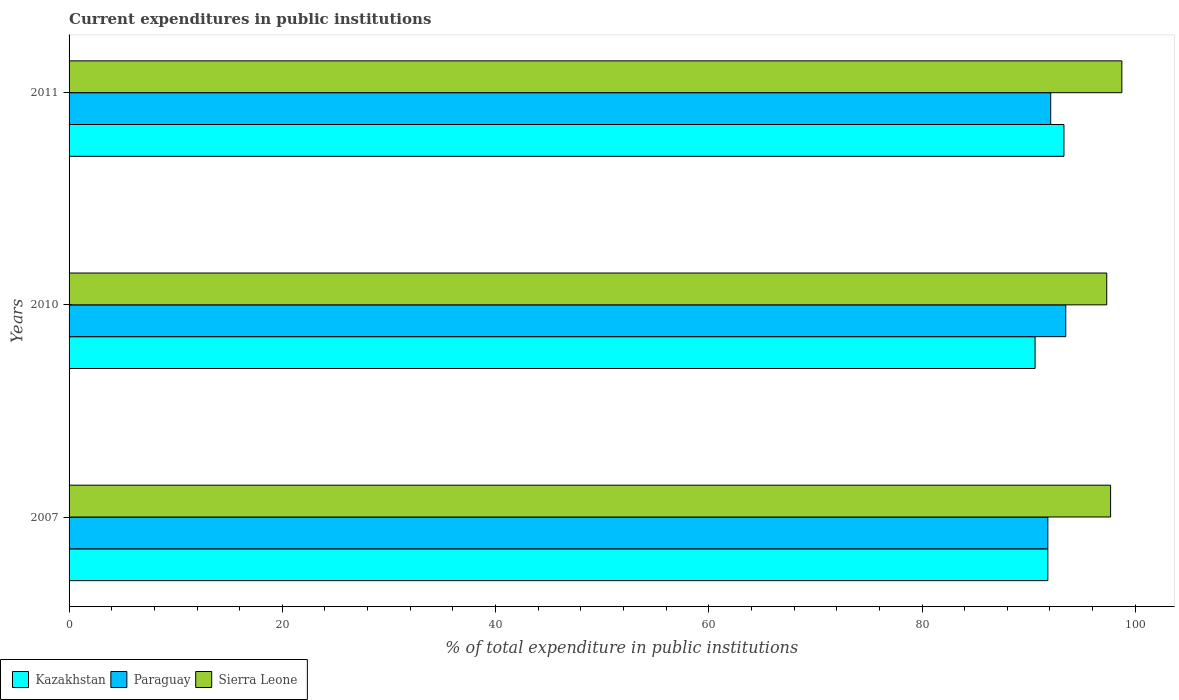How many different coloured bars are there?
Give a very brief answer. 3. Are the number of bars per tick equal to the number of legend labels?
Give a very brief answer. Yes. What is the current expenditures in public institutions in Sierra Leone in 2007?
Offer a terse response. 97.69. Across all years, what is the maximum current expenditures in public institutions in Kazakhstan?
Provide a succinct answer. 93.31. Across all years, what is the minimum current expenditures in public institutions in Sierra Leone?
Provide a short and direct response. 97.33. What is the total current expenditures in public institutions in Paraguay in the graph?
Give a very brief answer. 277.35. What is the difference between the current expenditures in public institutions in Sierra Leone in 2010 and that in 2011?
Give a very brief answer. -1.42. What is the difference between the current expenditures in public institutions in Kazakhstan in 2010 and the current expenditures in public institutions in Sierra Leone in 2011?
Make the answer very short. -8.14. What is the average current expenditures in public institutions in Kazakhstan per year?
Make the answer very short. 91.91. In the year 2007, what is the difference between the current expenditures in public institutions in Paraguay and current expenditures in public institutions in Sierra Leone?
Keep it short and to the point. -5.89. In how many years, is the current expenditures in public institutions in Sierra Leone greater than 4 %?
Ensure brevity in your answer.  3. What is the ratio of the current expenditures in public institutions in Kazakhstan in 2007 to that in 2010?
Your answer should be very brief. 1.01. Is the current expenditures in public institutions in Paraguay in 2010 less than that in 2011?
Keep it short and to the point. No. Is the difference between the current expenditures in public institutions in Paraguay in 2007 and 2011 greater than the difference between the current expenditures in public institutions in Sierra Leone in 2007 and 2011?
Keep it short and to the point. Yes. What is the difference between the highest and the second highest current expenditures in public institutions in Sierra Leone?
Ensure brevity in your answer.  1.06. What is the difference between the highest and the lowest current expenditures in public institutions in Paraguay?
Keep it short and to the point. 1.68. What does the 2nd bar from the top in 2010 represents?
Provide a succinct answer. Paraguay. What does the 2nd bar from the bottom in 2010 represents?
Your response must be concise. Paraguay. How many bars are there?
Offer a terse response. 9. Are the values on the major ticks of X-axis written in scientific E-notation?
Provide a short and direct response. No. Does the graph contain any zero values?
Offer a very short reply. No. Does the graph contain grids?
Ensure brevity in your answer.  No. How many legend labels are there?
Offer a terse response. 3. What is the title of the graph?
Offer a very short reply. Current expenditures in public institutions. What is the label or title of the X-axis?
Offer a terse response. % of total expenditure in public institutions. What is the label or title of the Y-axis?
Your answer should be very brief. Years. What is the % of total expenditure in public institutions of Kazakhstan in 2007?
Offer a terse response. 91.8. What is the % of total expenditure in public institutions in Paraguay in 2007?
Your response must be concise. 91.8. What is the % of total expenditure in public institutions in Sierra Leone in 2007?
Give a very brief answer. 97.69. What is the % of total expenditure in public institutions of Kazakhstan in 2010?
Give a very brief answer. 90.6. What is the % of total expenditure in public institutions of Paraguay in 2010?
Keep it short and to the point. 93.48. What is the % of total expenditure in public institutions of Sierra Leone in 2010?
Your response must be concise. 97.33. What is the % of total expenditure in public institutions in Kazakhstan in 2011?
Offer a terse response. 93.31. What is the % of total expenditure in public institutions of Paraguay in 2011?
Offer a terse response. 92.07. What is the % of total expenditure in public institutions in Sierra Leone in 2011?
Keep it short and to the point. 98.74. Across all years, what is the maximum % of total expenditure in public institutions in Kazakhstan?
Provide a succinct answer. 93.31. Across all years, what is the maximum % of total expenditure in public institutions in Paraguay?
Your response must be concise. 93.48. Across all years, what is the maximum % of total expenditure in public institutions in Sierra Leone?
Offer a very short reply. 98.74. Across all years, what is the minimum % of total expenditure in public institutions of Kazakhstan?
Your response must be concise. 90.6. Across all years, what is the minimum % of total expenditure in public institutions in Paraguay?
Offer a terse response. 91.8. Across all years, what is the minimum % of total expenditure in public institutions of Sierra Leone?
Your response must be concise. 97.33. What is the total % of total expenditure in public institutions in Kazakhstan in the graph?
Keep it short and to the point. 275.72. What is the total % of total expenditure in public institutions in Paraguay in the graph?
Offer a terse response. 277.36. What is the total % of total expenditure in public institutions of Sierra Leone in the graph?
Offer a terse response. 293.76. What is the difference between the % of total expenditure in public institutions in Kazakhstan in 2007 and that in 2010?
Ensure brevity in your answer.  1.2. What is the difference between the % of total expenditure in public institutions in Paraguay in 2007 and that in 2010?
Your answer should be very brief. -1.68. What is the difference between the % of total expenditure in public institutions of Sierra Leone in 2007 and that in 2010?
Make the answer very short. 0.36. What is the difference between the % of total expenditure in public institutions in Kazakhstan in 2007 and that in 2011?
Keep it short and to the point. -1.51. What is the difference between the % of total expenditure in public institutions in Paraguay in 2007 and that in 2011?
Provide a short and direct response. -0.27. What is the difference between the % of total expenditure in public institutions of Sierra Leone in 2007 and that in 2011?
Make the answer very short. -1.06. What is the difference between the % of total expenditure in public institutions of Kazakhstan in 2010 and that in 2011?
Offer a terse response. -2.71. What is the difference between the % of total expenditure in public institutions of Paraguay in 2010 and that in 2011?
Your response must be concise. 1.41. What is the difference between the % of total expenditure in public institutions of Sierra Leone in 2010 and that in 2011?
Provide a succinct answer. -1.42. What is the difference between the % of total expenditure in public institutions in Kazakhstan in 2007 and the % of total expenditure in public institutions in Paraguay in 2010?
Ensure brevity in your answer.  -1.68. What is the difference between the % of total expenditure in public institutions in Kazakhstan in 2007 and the % of total expenditure in public institutions in Sierra Leone in 2010?
Your response must be concise. -5.53. What is the difference between the % of total expenditure in public institutions in Paraguay in 2007 and the % of total expenditure in public institutions in Sierra Leone in 2010?
Offer a very short reply. -5.53. What is the difference between the % of total expenditure in public institutions in Kazakhstan in 2007 and the % of total expenditure in public institutions in Paraguay in 2011?
Your response must be concise. -0.27. What is the difference between the % of total expenditure in public institutions of Kazakhstan in 2007 and the % of total expenditure in public institutions of Sierra Leone in 2011?
Ensure brevity in your answer.  -6.94. What is the difference between the % of total expenditure in public institutions in Paraguay in 2007 and the % of total expenditure in public institutions in Sierra Leone in 2011?
Your answer should be compact. -6.94. What is the difference between the % of total expenditure in public institutions in Kazakhstan in 2010 and the % of total expenditure in public institutions in Paraguay in 2011?
Provide a succinct answer. -1.47. What is the difference between the % of total expenditure in public institutions in Kazakhstan in 2010 and the % of total expenditure in public institutions in Sierra Leone in 2011?
Give a very brief answer. -8.14. What is the difference between the % of total expenditure in public institutions in Paraguay in 2010 and the % of total expenditure in public institutions in Sierra Leone in 2011?
Keep it short and to the point. -5.26. What is the average % of total expenditure in public institutions of Kazakhstan per year?
Give a very brief answer. 91.91. What is the average % of total expenditure in public institutions of Paraguay per year?
Offer a terse response. 92.45. What is the average % of total expenditure in public institutions in Sierra Leone per year?
Provide a short and direct response. 97.92. In the year 2007, what is the difference between the % of total expenditure in public institutions of Kazakhstan and % of total expenditure in public institutions of Sierra Leone?
Keep it short and to the point. -5.89. In the year 2007, what is the difference between the % of total expenditure in public institutions of Paraguay and % of total expenditure in public institutions of Sierra Leone?
Your answer should be compact. -5.89. In the year 2010, what is the difference between the % of total expenditure in public institutions of Kazakhstan and % of total expenditure in public institutions of Paraguay?
Provide a succinct answer. -2.88. In the year 2010, what is the difference between the % of total expenditure in public institutions in Kazakhstan and % of total expenditure in public institutions in Sierra Leone?
Provide a succinct answer. -6.72. In the year 2010, what is the difference between the % of total expenditure in public institutions of Paraguay and % of total expenditure in public institutions of Sierra Leone?
Offer a very short reply. -3.84. In the year 2011, what is the difference between the % of total expenditure in public institutions in Kazakhstan and % of total expenditure in public institutions in Paraguay?
Your answer should be very brief. 1.24. In the year 2011, what is the difference between the % of total expenditure in public institutions of Kazakhstan and % of total expenditure in public institutions of Sierra Leone?
Offer a terse response. -5.43. In the year 2011, what is the difference between the % of total expenditure in public institutions in Paraguay and % of total expenditure in public institutions in Sierra Leone?
Make the answer very short. -6.67. What is the ratio of the % of total expenditure in public institutions of Kazakhstan in 2007 to that in 2010?
Your response must be concise. 1.01. What is the ratio of the % of total expenditure in public institutions of Paraguay in 2007 to that in 2010?
Provide a succinct answer. 0.98. What is the ratio of the % of total expenditure in public institutions of Sierra Leone in 2007 to that in 2010?
Give a very brief answer. 1. What is the ratio of the % of total expenditure in public institutions in Kazakhstan in 2007 to that in 2011?
Your answer should be compact. 0.98. What is the ratio of the % of total expenditure in public institutions in Paraguay in 2007 to that in 2011?
Your answer should be very brief. 1. What is the ratio of the % of total expenditure in public institutions of Sierra Leone in 2007 to that in 2011?
Provide a short and direct response. 0.99. What is the ratio of the % of total expenditure in public institutions in Kazakhstan in 2010 to that in 2011?
Your answer should be very brief. 0.97. What is the ratio of the % of total expenditure in public institutions in Paraguay in 2010 to that in 2011?
Provide a short and direct response. 1.02. What is the ratio of the % of total expenditure in public institutions of Sierra Leone in 2010 to that in 2011?
Keep it short and to the point. 0.99. What is the difference between the highest and the second highest % of total expenditure in public institutions in Kazakhstan?
Offer a very short reply. 1.51. What is the difference between the highest and the second highest % of total expenditure in public institutions in Paraguay?
Your response must be concise. 1.41. What is the difference between the highest and the second highest % of total expenditure in public institutions of Sierra Leone?
Provide a short and direct response. 1.06. What is the difference between the highest and the lowest % of total expenditure in public institutions in Kazakhstan?
Offer a very short reply. 2.71. What is the difference between the highest and the lowest % of total expenditure in public institutions in Paraguay?
Keep it short and to the point. 1.68. What is the difference between the highest and the lowest % of total expenditure in public institutions in Sierra Leone?
Your answer should be very brief. 1.42. 